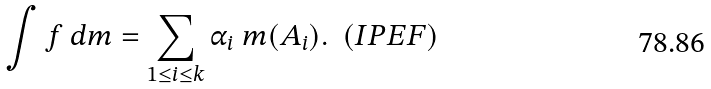Convert formula to latex. <formula><loc_0><loc_0><loc_500><loc_500>\int f \text { } d m = \sum _ { 1 \leq i \leq k } \alpha _ { i } \ m ( A _ { i } ) . \ \ ( I P E F )</formula> 